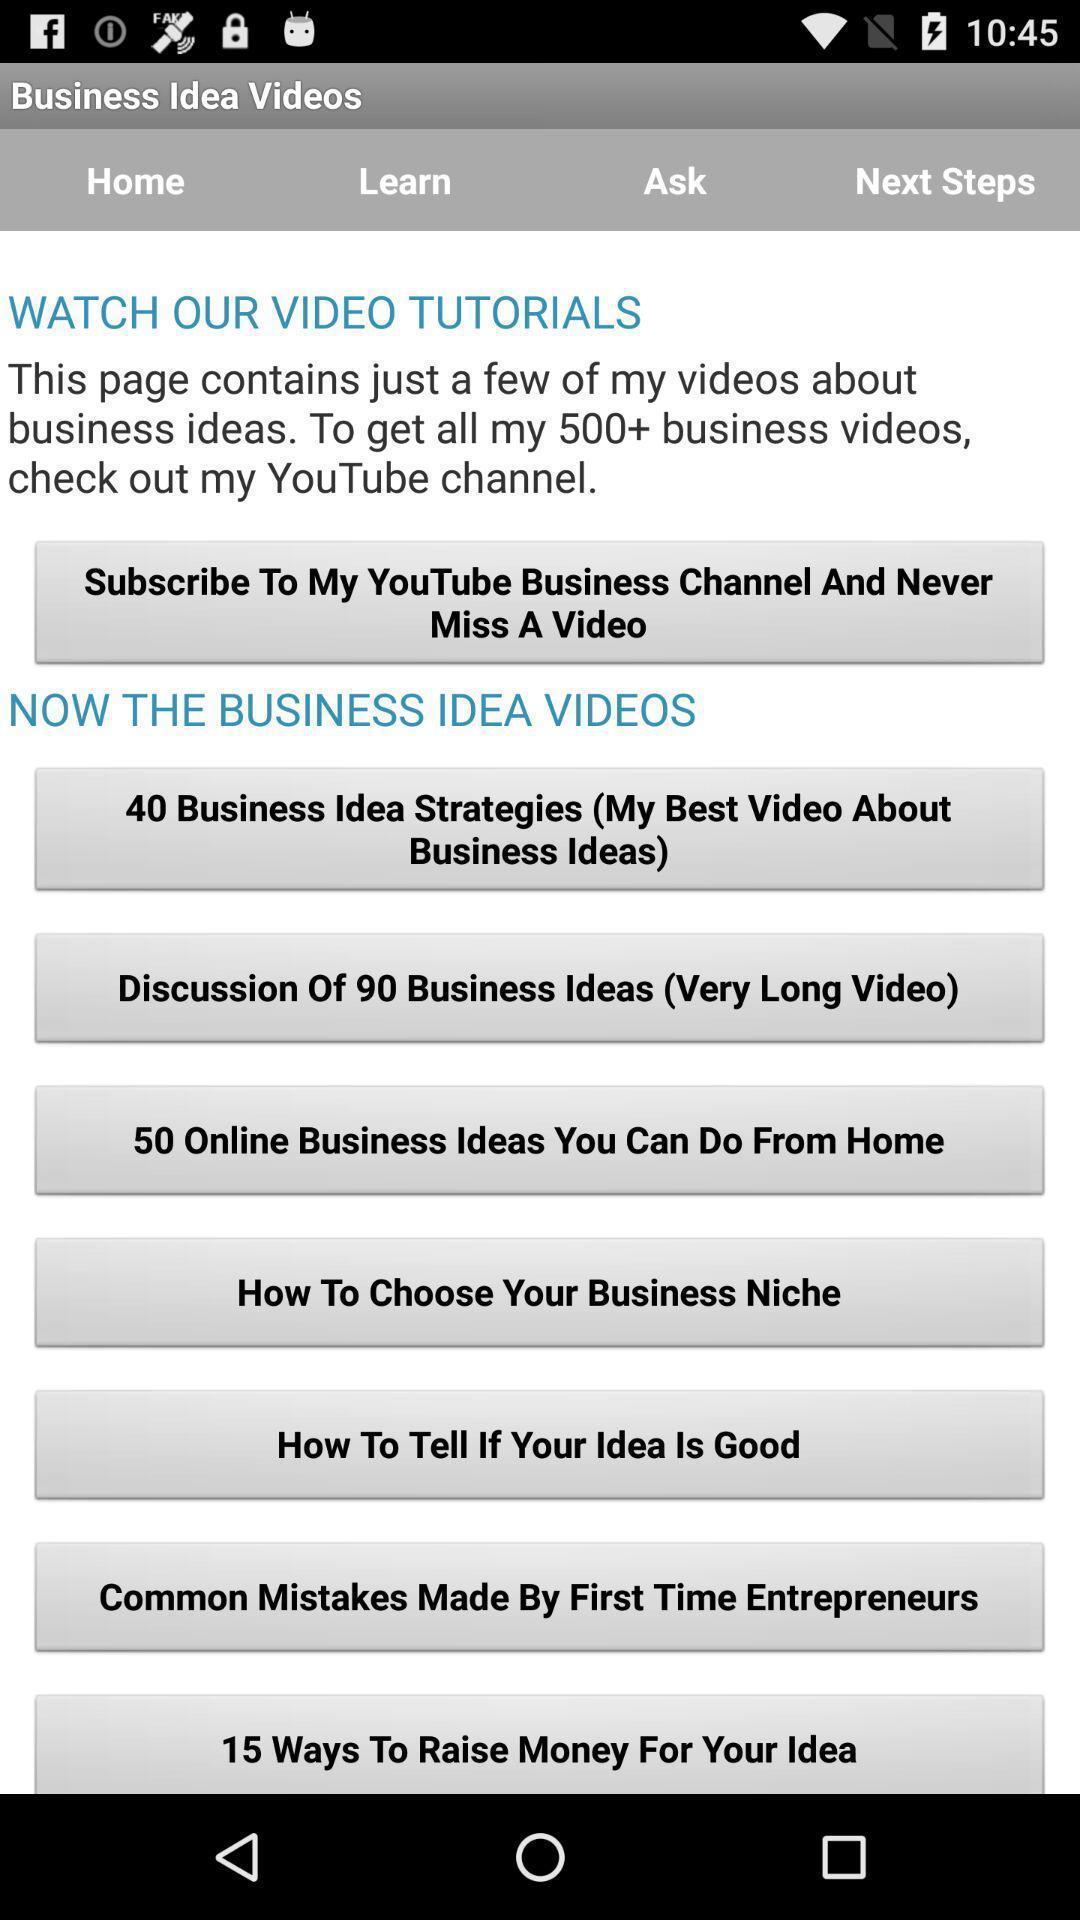Provide a description of this screenshot. Various video and article details displayed in business learning app. 